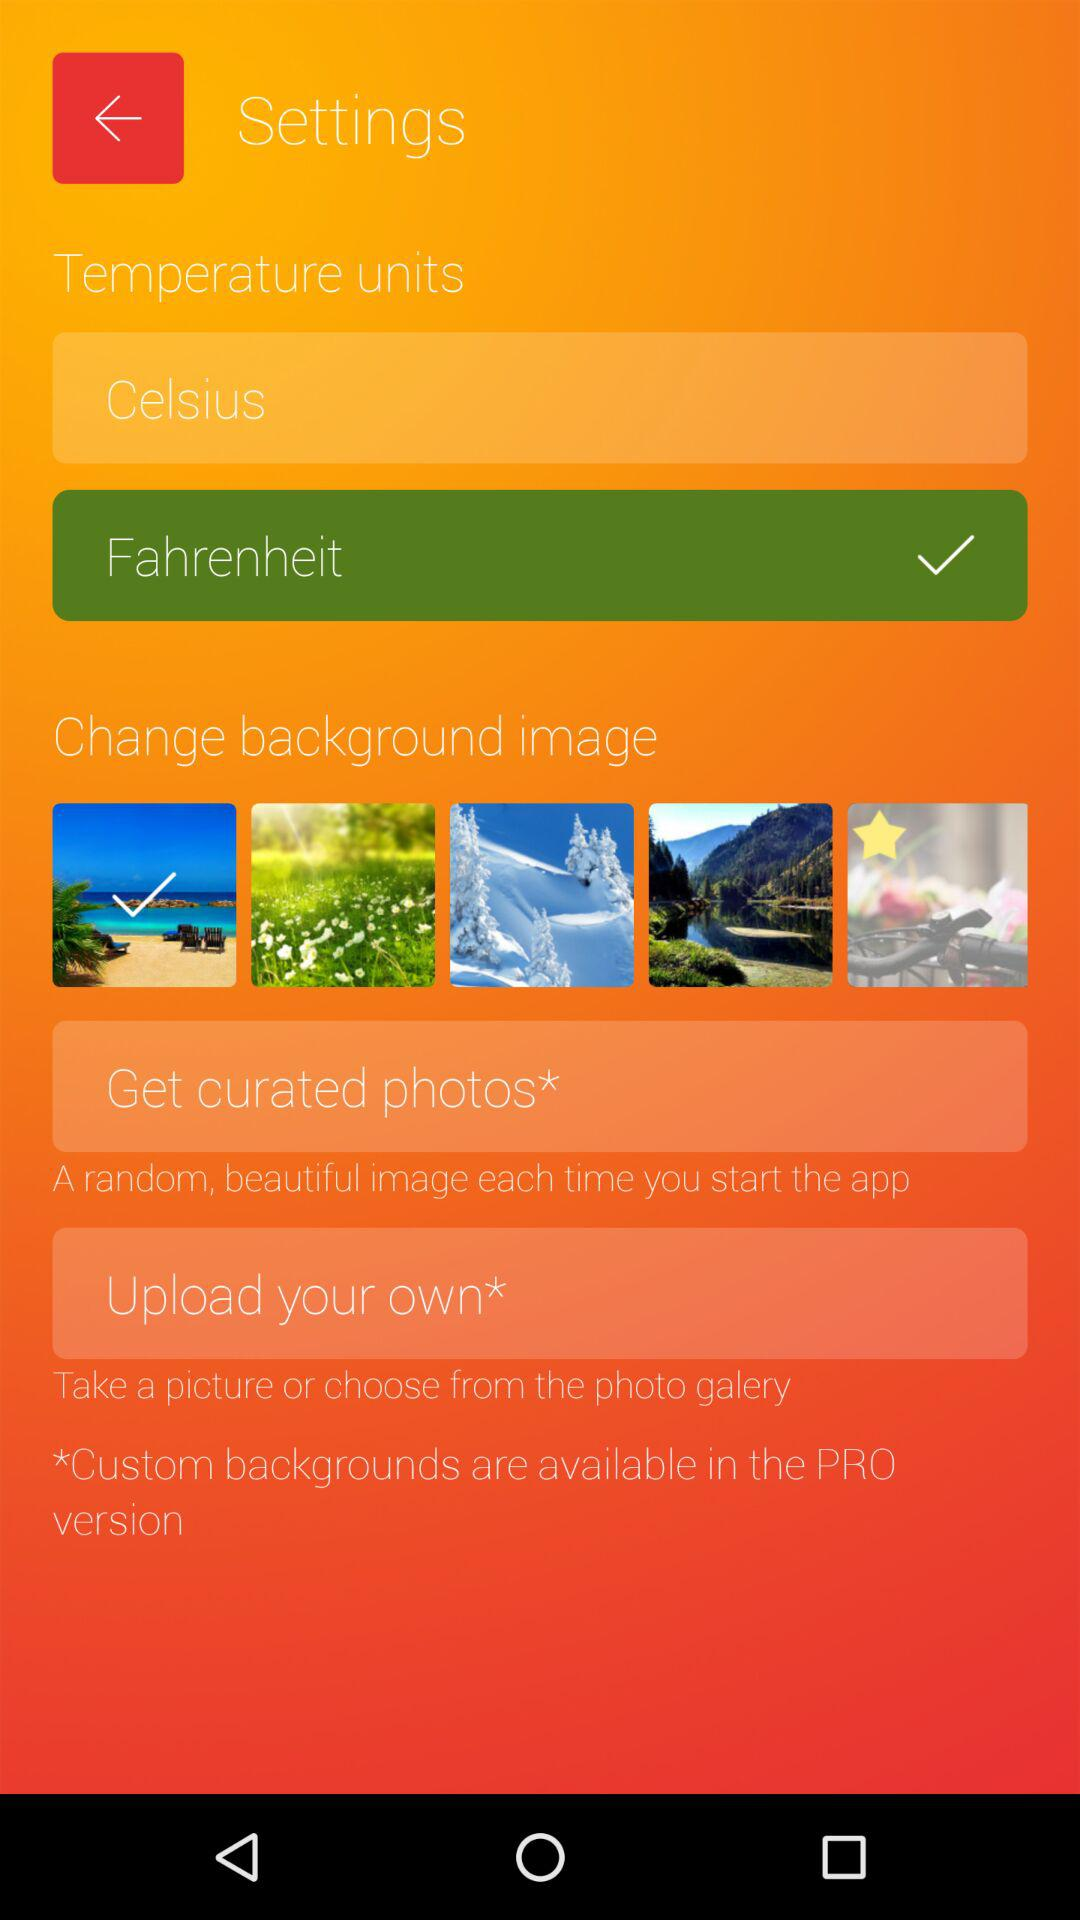How much does the PRO version cost?
When the provided information is insufficient, respond with <no answer>. <no answer> 